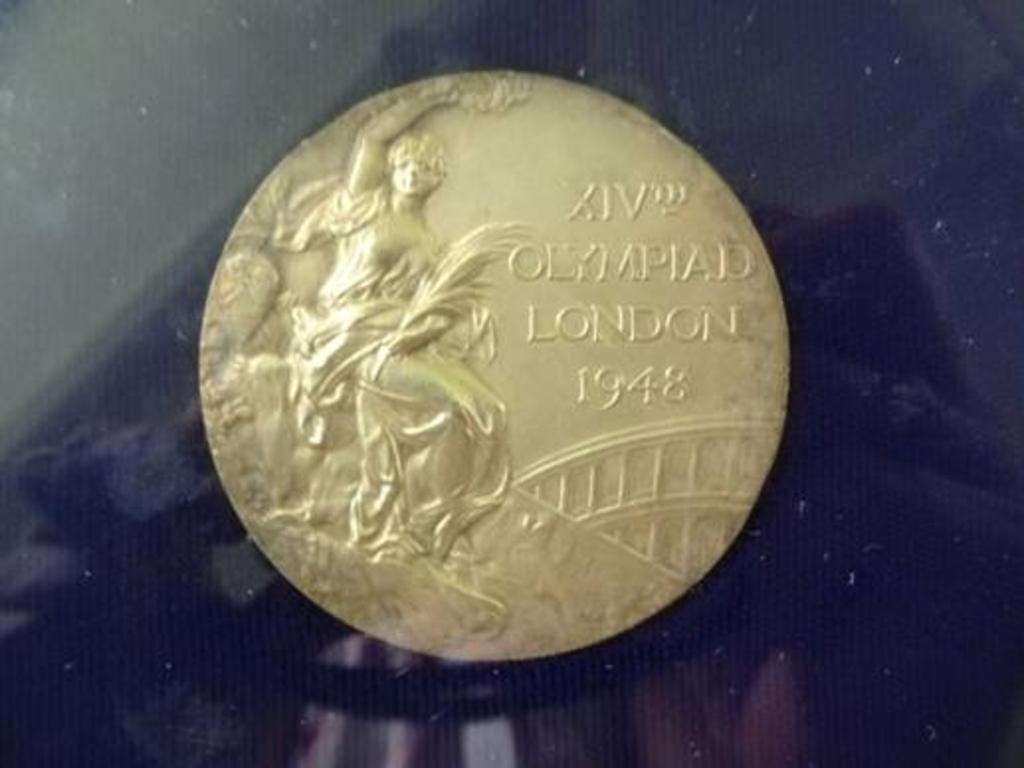<image>
Summarize the visual content of the image. Olympiad London 1948 is stamped into this collector coin. 